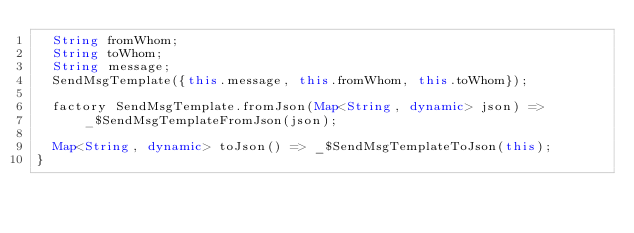Convert code to text. <code><loc_0><loc_0><loc_500><loc_500><_Dart_>  String fromWhom;
  String toWhom;
  String message;
  SendMsgTemplate({this.message, this.fromWhom, this.toWhom});

  factory SendMsgTemplate.fromJson(Map<String, dynamic> json) =>
      _$SendMsgTemplateFromJson(json);

  Map<String, dynamic> toJson() => _$SendMsgTemplateToJson(this);
}
</code> 